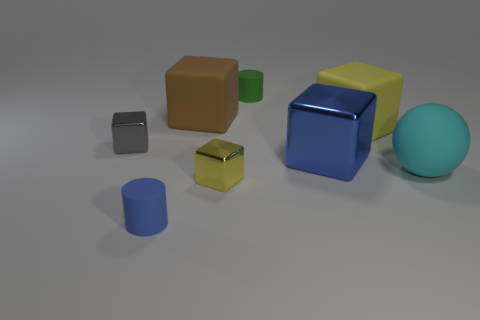There is a metallic cube on the left side of the tiny cylinder in front of the big cyan object; what number of big rubber cubes are in front of it?
Offer a very short reply. 0. What is the size of the cyan object?
Make the answer very short. Large. What is the material of the sphere that is the same size as the brown cube?
Ensure brevity in your answer.  Rubber. What number of tiny things are in front of the green cylinder?
Offer a terse response. 3. Is the yellow thing in front of the cyan ball made of the same material as the yellow block right of the tiny yellow object?
Keep it short and to the point. No. What is the shape of the blue thing on the right side of the tiny rubber cylinder left of the small block in front of the small gray block?
Give a very brief answer. Cube. There is a green thing; what shape is it?
Provide a short and direct response. Cylinder. What is the shape of the cyan object that is the same size as the blue shiny object?
Provide a succinct answer. Sphere. What number of other things are the same color as the big metallic object?
Your response must be concise. 1. Does the small object right of the tiny yellow shiny object have the same shape as the metallic thing that is right of the green thing?
Your answer should be compact. No. 